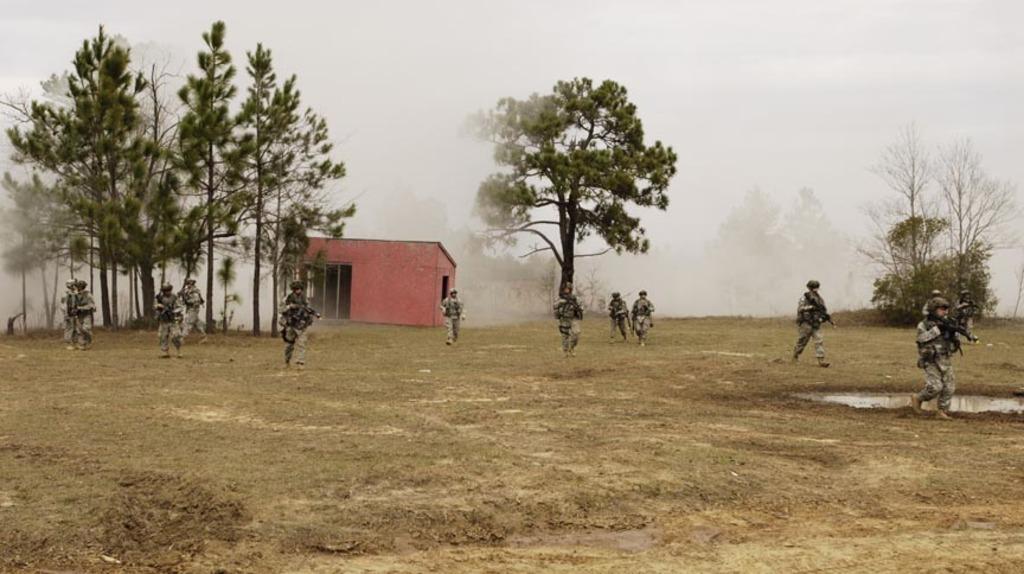Could you give a brief overview of what you see in this image? In this image there are group of military officers who are walking on the ground. In the background there is a small house in between the trees. At the top there is smoke. All the military officers are walking on the ground by holding the guns in their hands. On the right side there is water on the ground. 